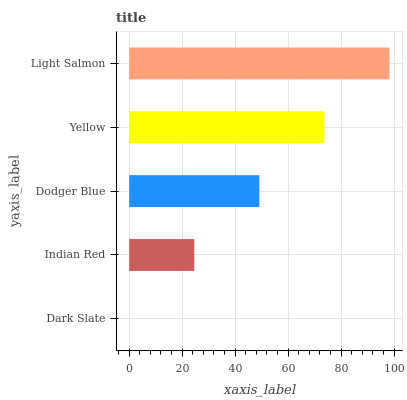Is Dark Slate the minimum?
Answer yes or no. Yes. Is Light Salmon the maximum?
Answer yes or no. Yes. Is Indian Red the minimum?
Answer yes or no. No. Is Indian Red the maximum?
Answer yes or no. No. Is Indian Red greater than Dark Slate?
Answer yes or no. Yes. Is Dark Slate less than Indian Red?
Answer yes or no. Yes. Is Dark Slate greater than Indian Red?
Answer yes or no. No. Is Indian Red less than Dark Slate?
Answer yes or no. No. Is Dodger Blue the high median?
Answer yes or no. Yes. Is Dodger Blue the low median?
Answer yes or no. Yes. Is Yellow the high median?
Answer yes or no. No. Is Dark Slate the low median?
Answer yes or no. No. 